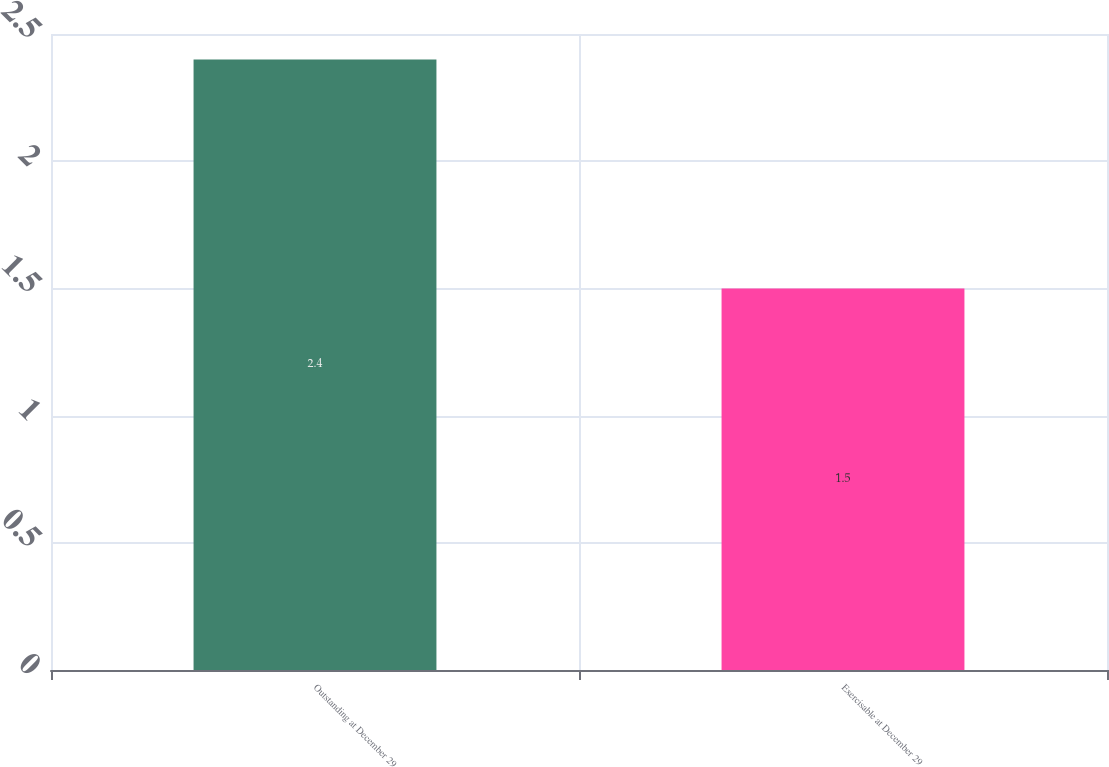Convert chart. <chart><loc_0><loc_0><loc_500><loc_500><bar_chart><fcel>Outstanding at December 29<fcel>Exercisable at December 29<nl><fcel>2.4<fcel>1.5<nl></chart> 